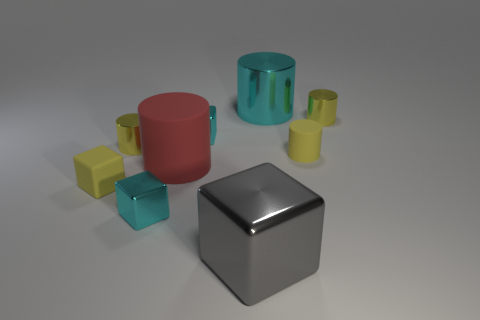Subtract all yellow cylinders. How many were subtracted if there are1yellow cylinders left? 2 Subtract all big rubber cylinders. How many cylinders are left? 4 Add 1 red rubber cylinders. How many objects exist? 10 Subtract all yellow cylinders. How many cylinders are left? 2 Subtract all blocks. How many objects are left? 5 Subtract 2 cylinders. How many cylinders are left? 3 Subtract all cyan cylinders. Subtract all blue blocks. How many cylinders are left? 4 Subtract all green spheres. How many purple cubes are left? 0 Subtract all tiny brown metal objects. Subtract all small cyan objects. How many objects are left? 7 Add 7 yellow cylinders. How many yellow cylinders are left? 10 